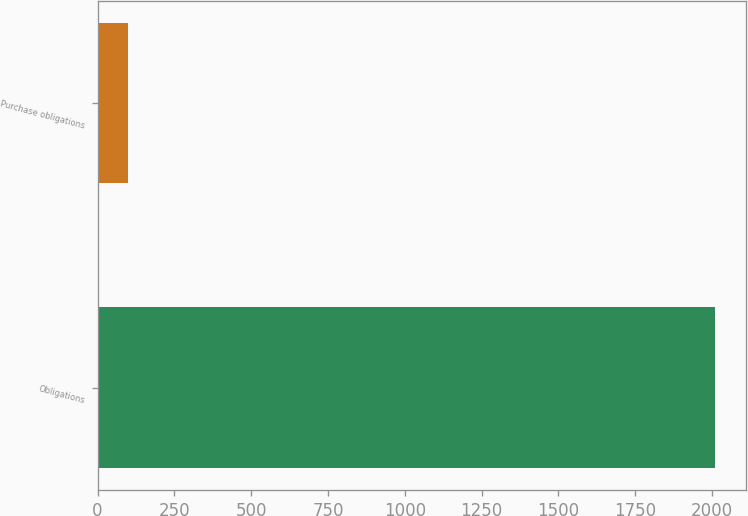<chart> <loc_0><loc_0><loc_500><loc_500><bar_chart><fcel>Obligations<fcel>Purchase obligations<nl><fcel>2011<fcel>99.3<nl></chart> 